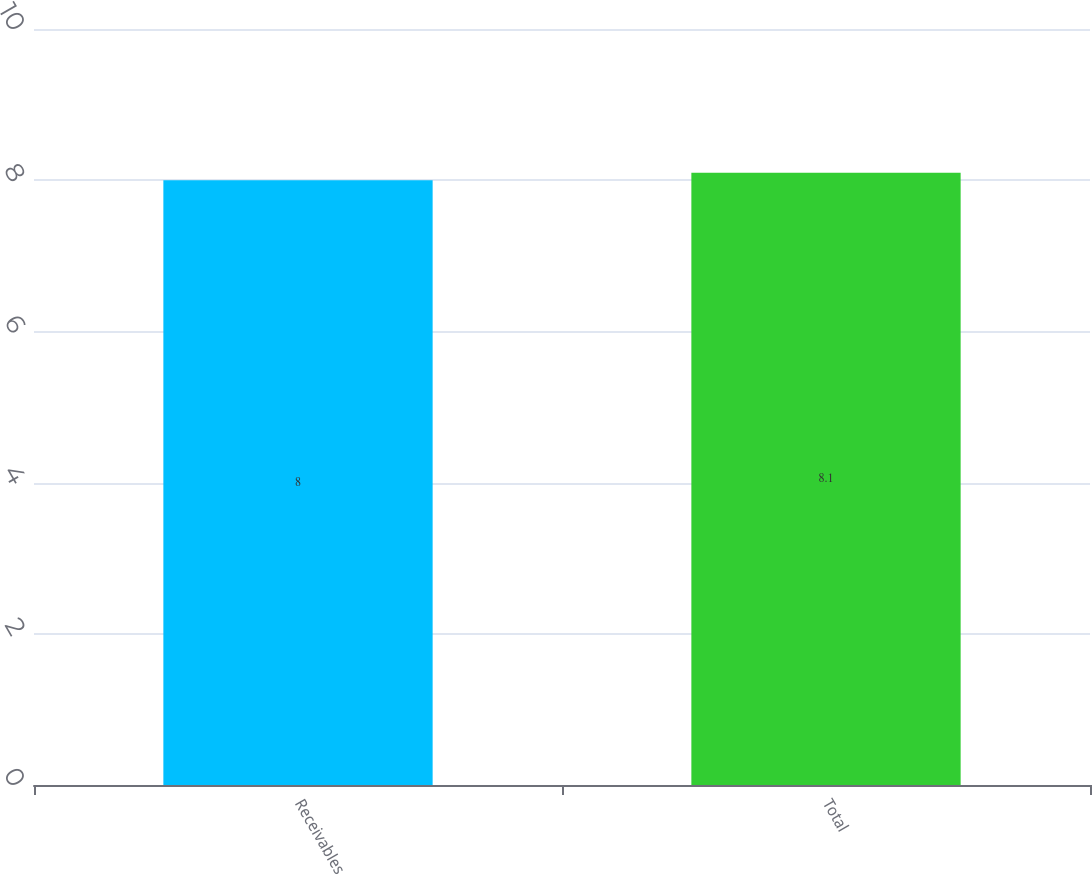Convert chart to OTSL. <chart><loc_0><loc_0><loc_500><loc_500><bar_chart><fcel>Receivables<fcel>Total<nl><fcel>8<fcel>8.1<nl></chart> 